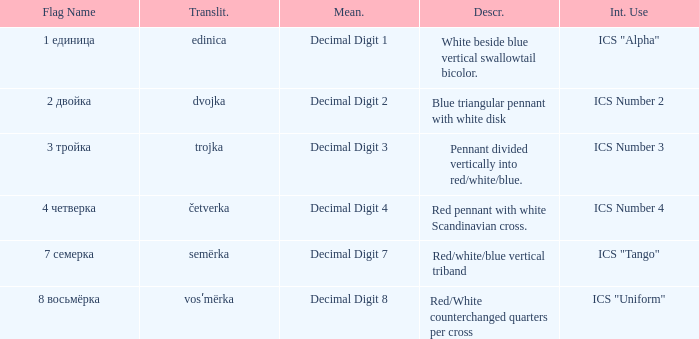What is the name of the flag that means decimal digit 2? 2 двойка. 